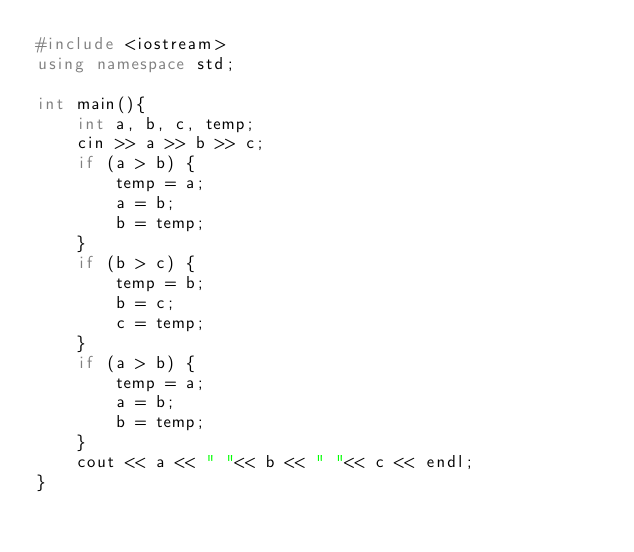<code> <loc_0><loc_0><loc_500><loc_500><_C++_>#include <iostream>
using namespace std;

int main(){
    int a, b, c, temp;
    cin >> a >> b >> c;
    if (a > b) {
        temp = a;
        a = b;
        b = temp;
    }
    if (b > c) {
        temp = b;
        b = c;
        c = temp;
    }
    if (a > b) {
        temp = a;
        a = b;
        b = temp;
    }
    cout << a << " "<< b << " "<< c << endl;
}
</code> 